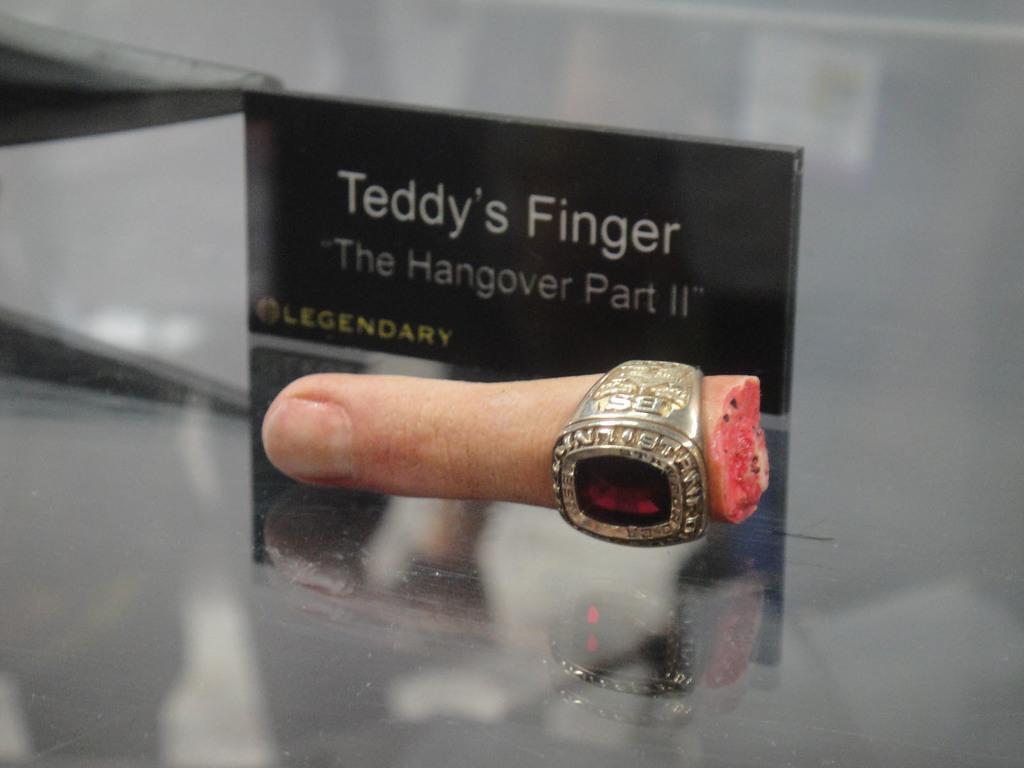How would you summarize this image in a sentence or two? In this picture I can see a ring in the finger. In the background I can see something written on the black color object. These objects are on a surface. 